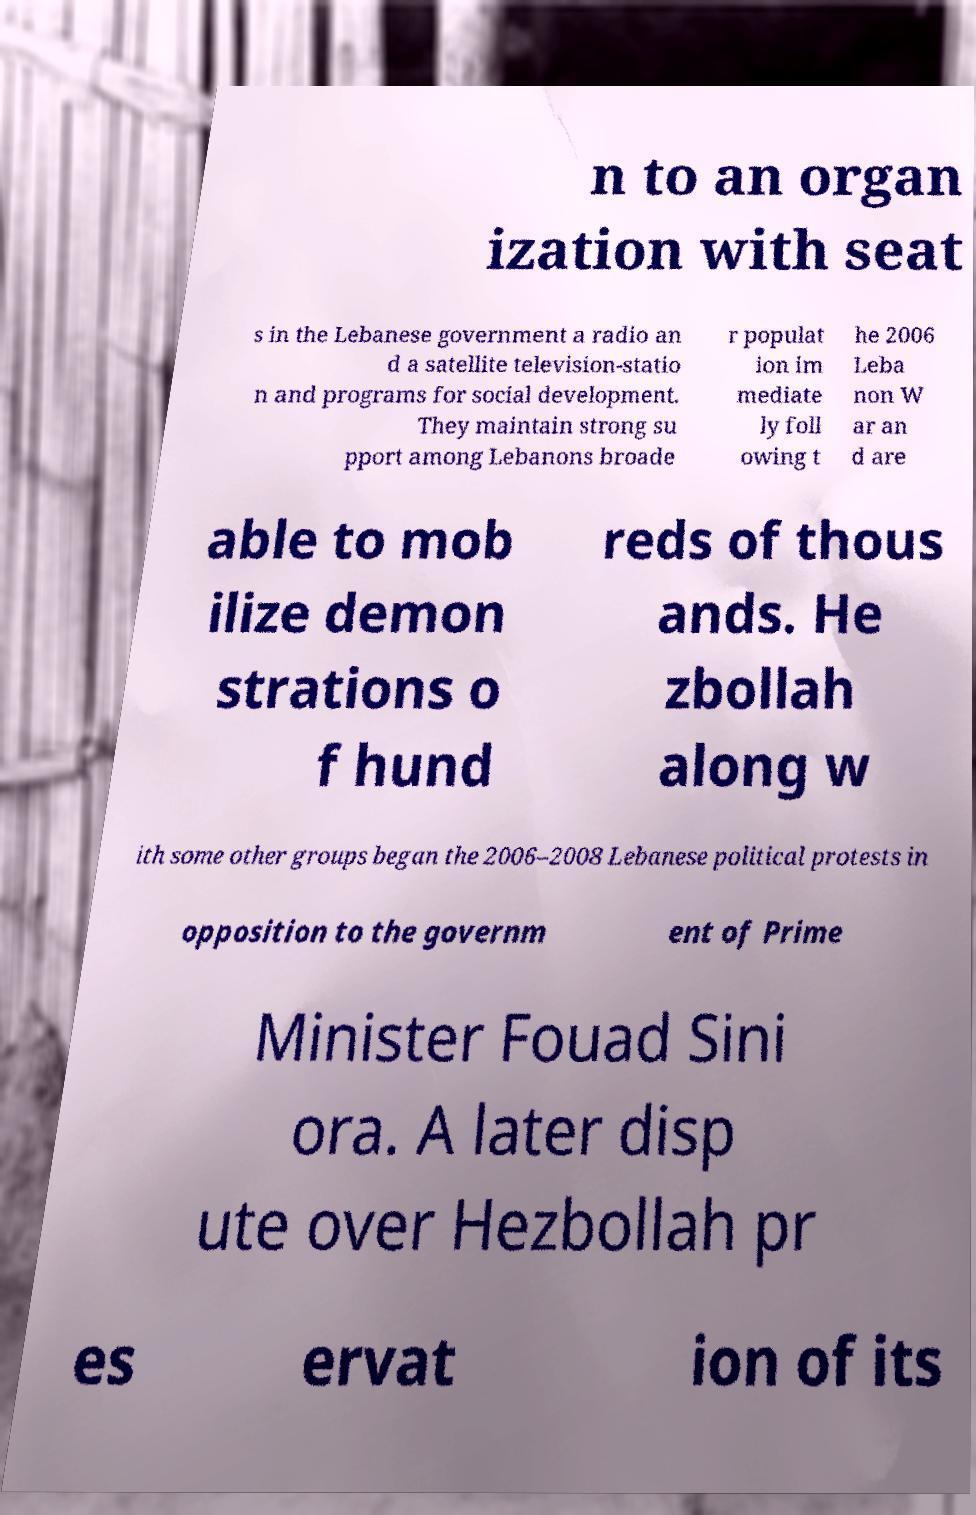Please read and relay the text visible in this image. What does it say? n to an organ ization with seat s in the Lebanese government a radio an d a satellite television-statio n and programs for social development. They maintain strong su pport among Lebanons broade r populat ion im mediate ly foll owing t he 2006 Leba non W ar an d are able to mob ilize demon strations o f hund reds of thous ands. He zbollah along w ith some other groups began the 2006–2008 Lebanese political protests in opposition to the governm ent of Prime Minister Fouad Sini ora. A later disp ute over Hezbollah pr es ervat ion of its 